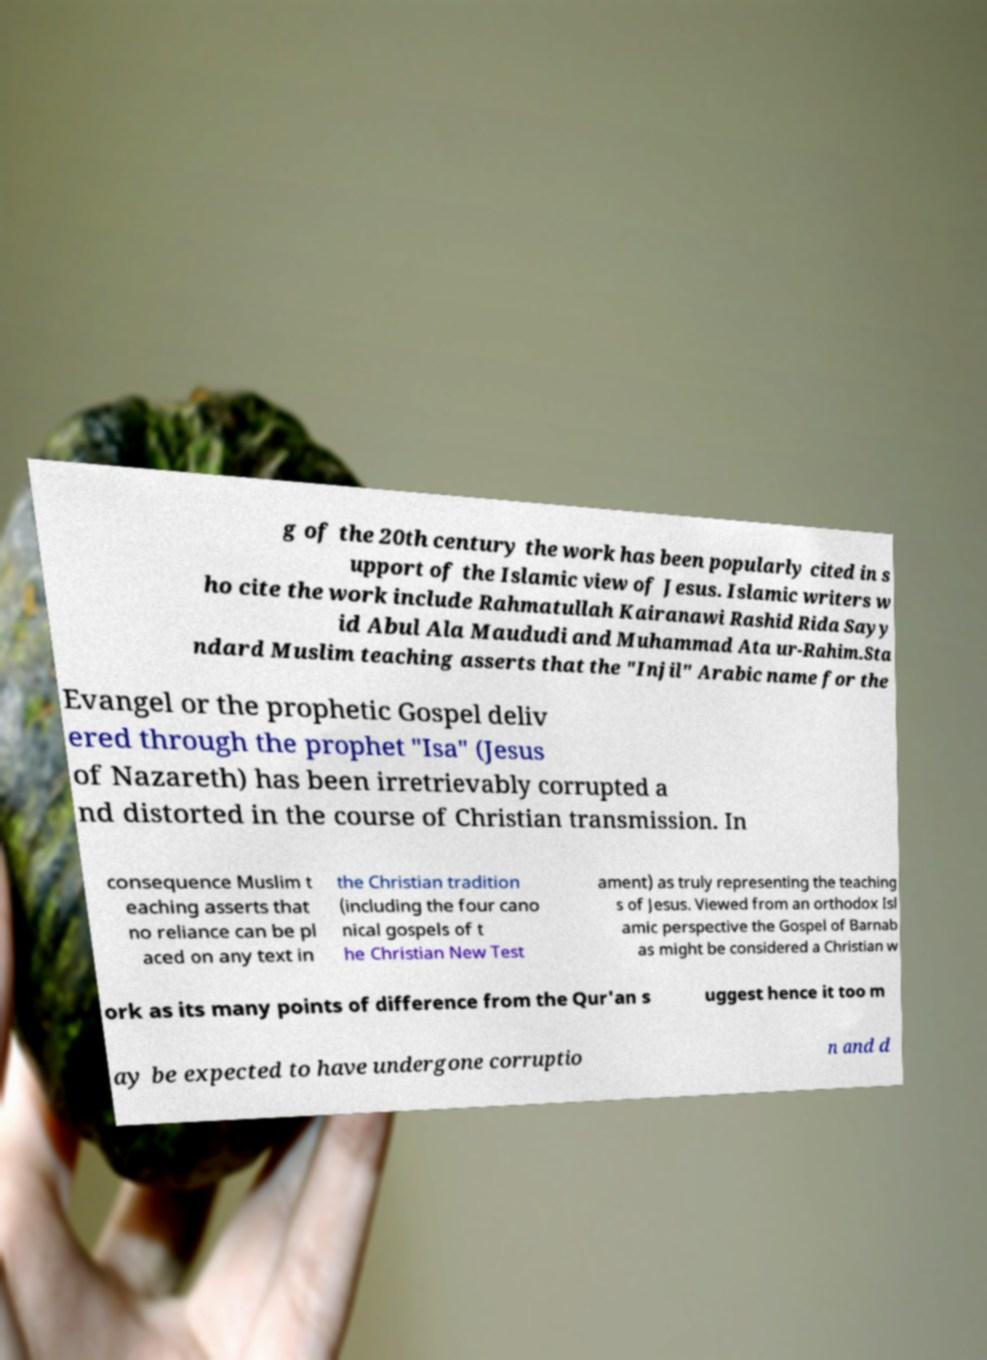Could you extract and type out the text from this image? g of the 20th century the work has been popularly cited in s upport of the Islamic view of Jesus. Islamic writers w ho cite the work include Rahmatullah Kairanawi Rashid Rida Sayy id Abul Ala Maududi and Muhammad Ata ur-Rahim.Sta ndard Muslim teaching asserts that the "Injil" Arabic name for the Evangel or the prophetic Gospel deliv ered through the prophet "Isa" (Jesus of Nazareth) has been irretrievably corrupted a nd distorted in the course of Christian transmission. In consequence Muslim t eaching asserts that no reliance can be pl aced on any text in the Christian tradition (including the four cano nical gospels of t he Christian New Test ament) as truly representing the teaching s of Jesus. Viewed from an orthodox Isl amic perspective the Gospel of Barnab as might be considered a Christian w ork as its many points of difference from the Qur'an s uggest hence it too m ay be expected to have undergone corruptio n and d 